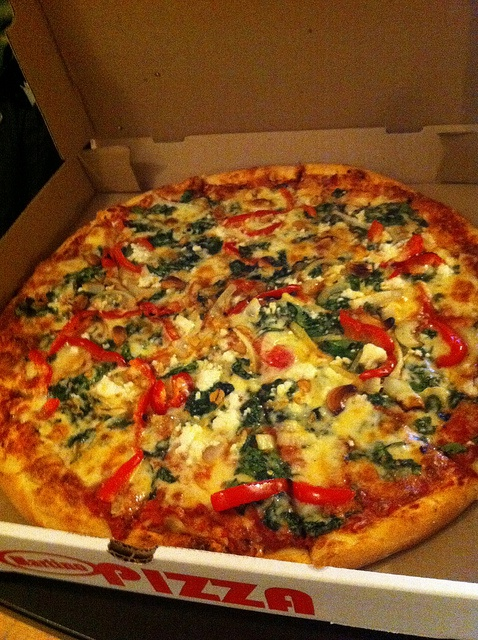Describe the objects in this image and their specific colors. I can see a pizza in black, brown, maroon, and orange tones in this image. 